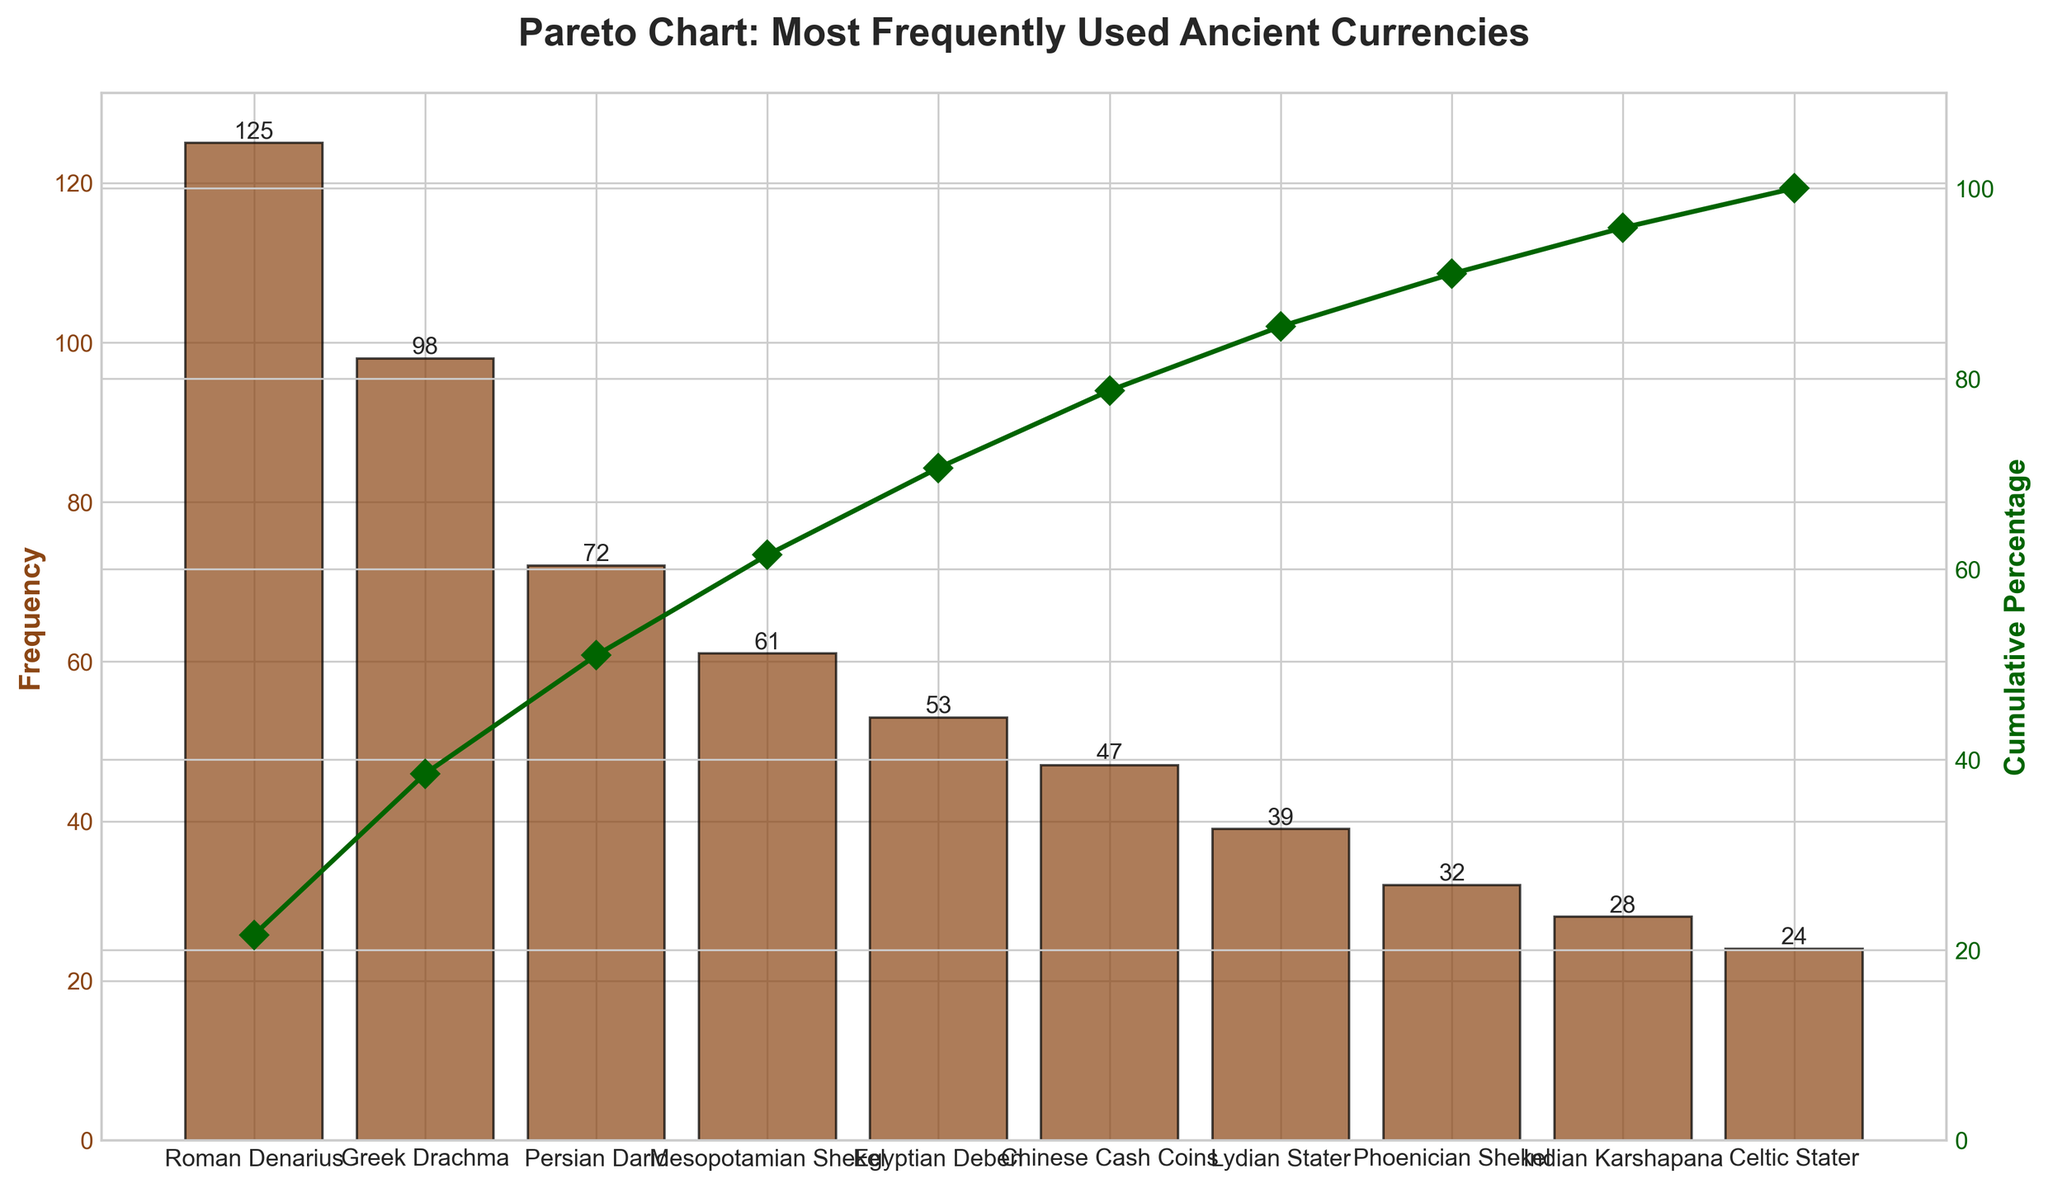Which currency has the highest frequency in the Pareto chart? The Roman Denarius has the highest frequency because its bar reaches the highest point on the leftmost side of the chart.
Answer: Roman Denarius Which civilization is linked to the second most frequently used currency in historical research? The Greek Drachma is second on the list and it's linked to the Greek civilization, as it's right after the Roman Denarius.
Answer: Greek What is the cumulative percentage of the top three most frequently used currencies? Sum the cumulative percentages of the Roman Denarius (125), Greek Drachma (98), and Persian Daric (72) from the chart: 125/609 * 100 + 98/609 * 100 + 72/609 * 100 ≈ 20.5% + 16.1% + 11.8% ≈ 48.4%.
Answer: 48.4% How many currencies cumulatively make up 75% of the frequencies? Observe the cumulative percentage line. The Roman Denarius, Greek Drachma, Persian Daric, Mesopotamian Shekel, and Egyptian Deben together reach approximately 75%.
Answer: 5 What is the combined frequency of Chinese Cash Coins and Phoenician Shekel? Adding their frequencies from the chart: 47 (Chinese Cash Coins) + 32 (Phoenician Shekel) = 79.
Answer: 79 Which currency shows a frequency very close to 50 in the chart? The Egyptian Deben has a frequency of 53, which is closest to 50 among the currencies listed.
Answer: Egyptian Deben Compare the frequency of Lydian Stater and Indian Karshapana. Which is higher and by how much? Lydian Stater has a frequency of 39 and Indian Karshapana has 28. The difference is 39 - 28 = 11.
Answer: Lydian Stater; 11 What percentage of the total frequency is made up by Celtic Stater? Celtic Stater's frequency is 24. To find the percentage, calculate 24/609 * 100 ≈ 3.9%.
Answer: 3.9% Is the cumulative percentage line increasing faster in the beginning or towards the end of the chart? The cumulative percentage line increases more steeply at the beginning, indicating that a few currencies contribute significantly to the total frequency, whereas it flattens toward the end.
Answer: Beginning 